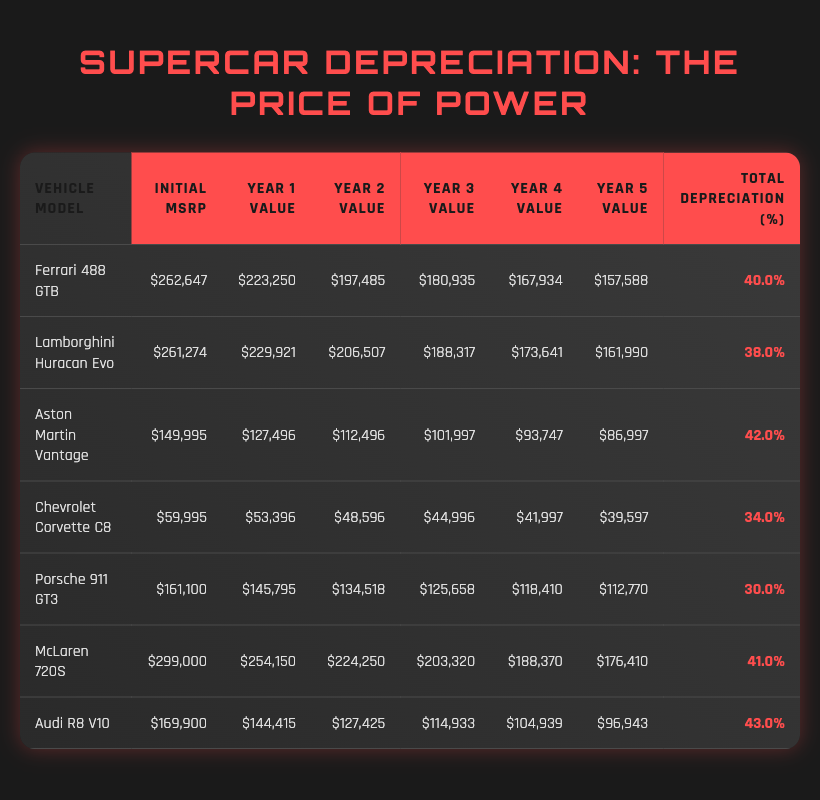What is the total depreciation percentage of the Lamborghini Huracan Evo? According to the table, the total depreciation percentage for the Lamborghini Huracan Evo is directly listed in the last column as 38.0%.
Answer: 38.0% Which vehicle has the highest initial MSRP? By comparing all the initial MSRP values in the table, the McLaren 720S has the highest initial MSRP of $299,000.
Answer: McLaren 720S What is the average total depreciation percentage of the vehicles listed? To calculate the average total depreciation percentage, add up all the depreciation values: 40.0 + 38.0 + 42.0 + 34.0 + 30.0 + 41.0 + 43.0 = 268.0. Then divide by the number of vehicles (7): 268.0 / 7 = 38.2857, which rounds to 38.29%.
Answer: 38.29% Is the total depreciation of the Porsche 911 GT3 greater than that of the Chevrolet Corvette C8? The total depreciation percentage for the Porsche 911 GT3 is 30.0% and for the Chevrolet Corvette C8 is 34.0%. Since 30.0% is not greater than 34.0%, the statement is false.
Answer: No What is the difference in the Year 5 value between the Audi R8 V10 and the Aston Martin Vantage? The Year 5 value for the Audi R8 V10 is $96,943 and for the Aston Martin Vantage is $86,997. The difference is calculated by subtracting the Vantage's value from the R8's value: $96,943 - $86,997 = $9,946.
Answer: $9,946 